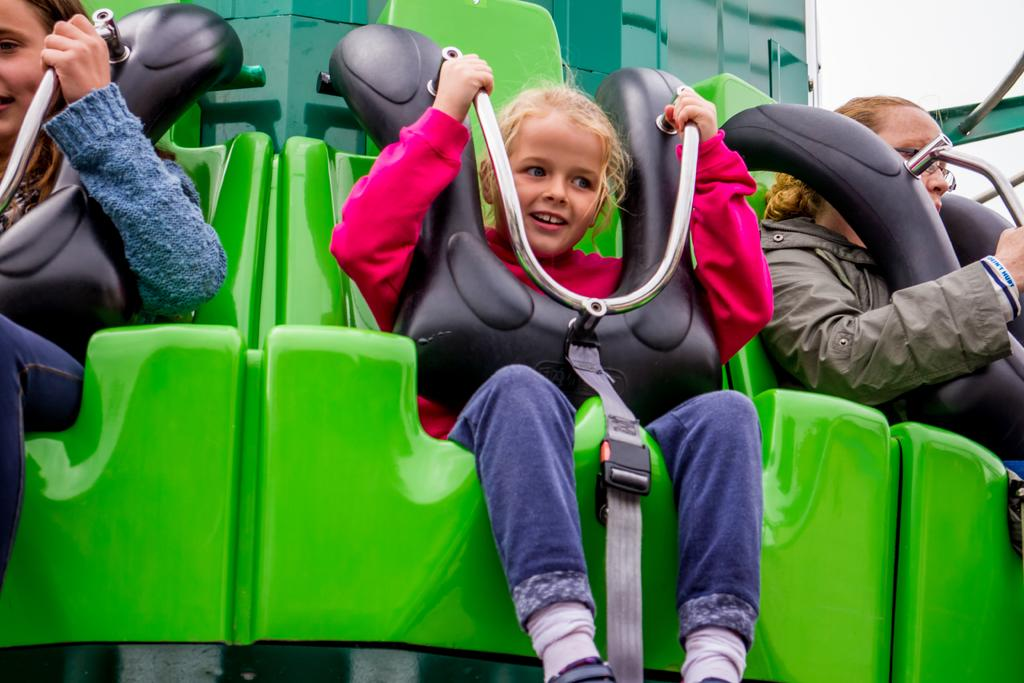How many people are in the image? There are three persons in the image. What are the persons doing in the image? The persons are sitting on an exhibition ride. What colors can be seen on the exhibition ride? The exhibition ride is green and black in color. What can be seen in the background of the image? The sky is visible in the background of the image. How many knots are tied on the persons' clothing in the image? There is no mention of knots or any specific clothing in the image, so it is not possible to determine the number of knots. 